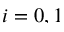<formula> <loc_0><loc_0><loc_500><loc_500>i = 0 , 1</formula> 